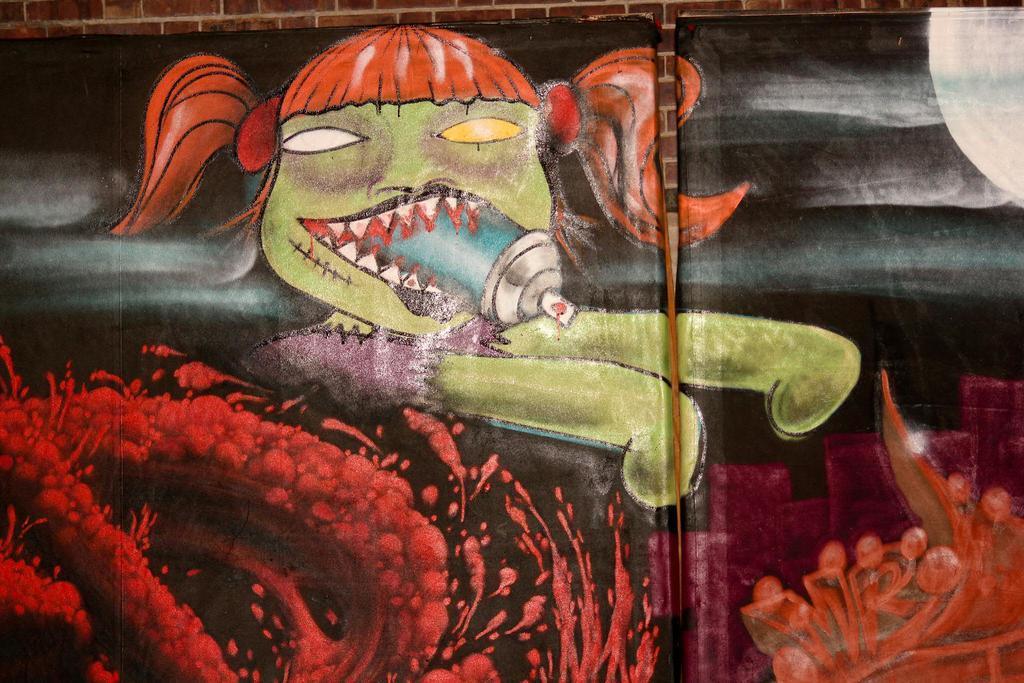How would you summarize this image in a sentence or two? Here in this picture we can see a wall and on that we can see a black colored chart pasted with some kind of paintings drawn on it over there. 